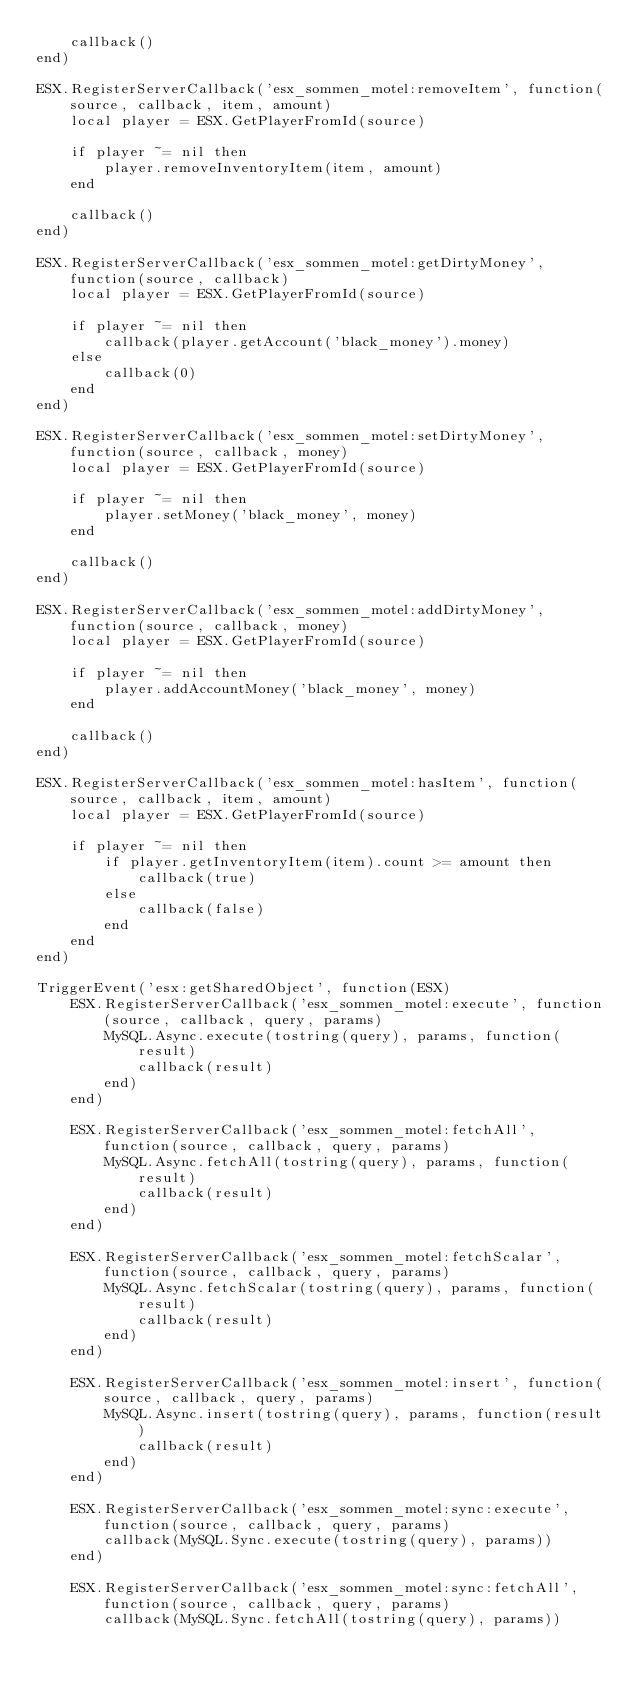<code> <loc_0><loc_0><loc_500><loc_500><_Lua_>	callback()
end)

ESX.RegisterServerCallback('esx_sommen_motel:removeItem', function(source, callback, item, amount)
	local player = ESX.GetPlayerFromId(source)

	if player ~= nil then
		player.removeInventoryItem(item, amount)
	end

	callback()
end)

ESX.RegisterServerCallback('esx_sommen_motel:getDirtyMoney', function(source, callback)
	local player = ESX.GetPlayerFromId(source)

	if player ~= nil then
		callback(player.getAccount('black_money').money)
	else
		callback(0)
	end
end)

ESX.RegisterServerCallback('esx_sommen_motel:setDirtyMoney', function(source, callback, money)
	local player = ESX.GetPlayerFromId(source)

	if player ~= nil then
		player.setMoney('black_money', money)
	end

	callback()
end)

ESX.RegisterServerCallback('esx_sommen_motel:addDirtyMoney', function(source, callback, money)
	local player = ESX.GetPlayerFromId(source)

	if player ~= nil then
		player.addAccountMoney('black_money', money)
	end

	callback()
end)

ESX.RegisterServerCallback('esx_sommen_motel:hasItem', function(source, callback, item, amount)
	local player = ESX.GetPlayerFromId(source)

	if player ~= nil then
		if player.getInventoryItem(item).count >= amount then
			callback(true)
		else
			callback(false)
		end
	end
end)

TriggerEvent('esx:getSharedObject', function(ESX)
	ESX.RegisterServerCallback('esx_sommen_motel:execute', function(source, callback, query, params)
		MySQL.Async.execute(tostring(query), params, function(result)
			callback(result)
		end)
	end)

	ESX.RegisterServerCallback('esx_sommen_motel:fetchAll', function(source, callback, query, params)
		MySQL.Async.fetchAll(tostring(query), params, function(result)
			callback(result)
		end)
	end)

	ESX.RegisterServerCallback('esx_sommen_motel:fetchScalar', function(source, callback, query, params)
		MySQL.Async.fetchScalar(tostring(query), params, function(result)
			callback(result)
		end)
	end)

	ESX.RegisterServerCallback('esx_sommen_motel:insert', function(source, callback, query, params)
		MySQL.Async.insert(tostring(query), params, function(result)
			callback(result)
		end)
	end)

	ESX.RegisterServerCallback('esx_sommen_motel:sync:execute', function(source, callback, query, params)
		callback(MySQL.Sync.execute(tostring(query), params))
	end)

	ESX.RegisterServerCallback('esx_sommen_motel:sync:fetchAll', function(source, callback, query, params)
		callback(MySQL.Sync.fetchAll(tostring(query), params))</code> 